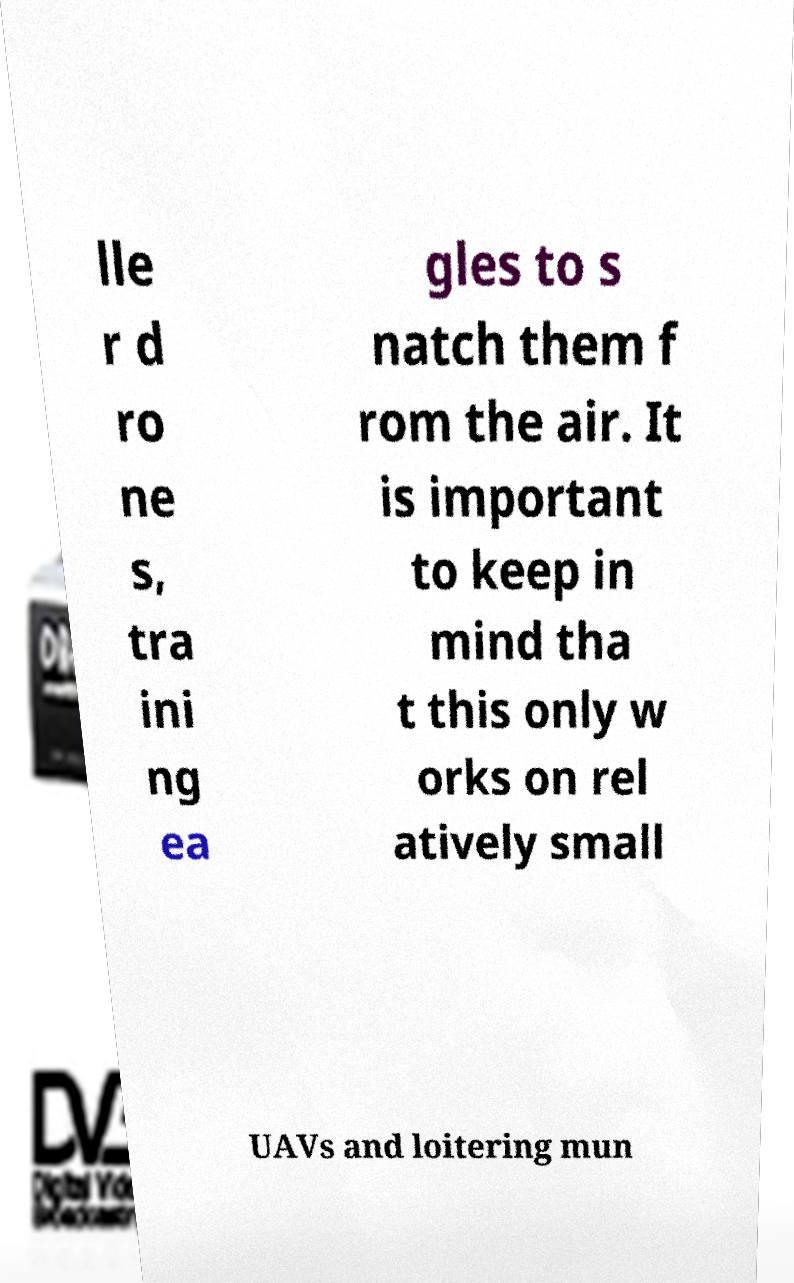Could you extract and type out the text from this image? lle r d ro ne s, tra ini ng ea gles to s natch them f rom the air. It is important to keep in mind tha t this only w orks on rel atively small UAVs and loitering mun 